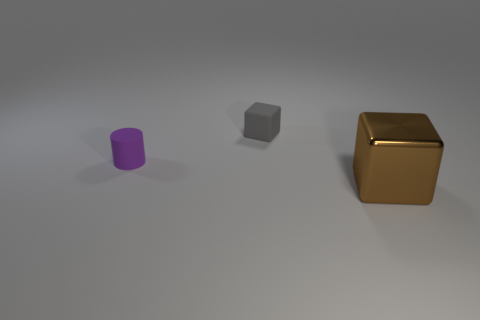Subtract all brown blocks. How many blocks are left? 1 Subtract 1 cylinders. How many cylinders are left? 0 Add 3 small purple things. How many objects exist? 6 Subtract all blocks. How many objects are left? 1 Add 1 small brown cylinders. How many small brown cylinders exist? 1 Subtract 0 purple spheres. How many objects are left? 3 Subtract all brown blocks. Subtract all blue cylinders. How many blocks are left? 1 Subtract all big brown metallic balls. Subtract all gray matte blocks. How many objects are left? 2 Add 3 metal objects. How many metal objects are left? 4 